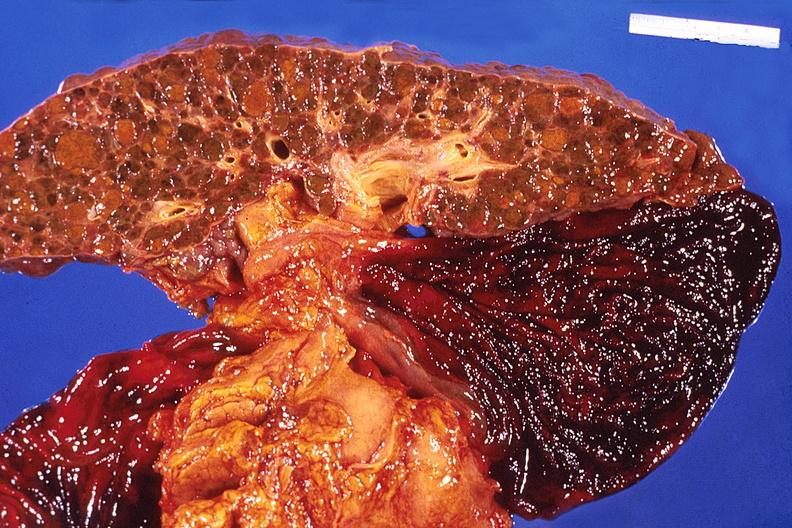s disease present?
Answer the question using a single word or phrase. No 